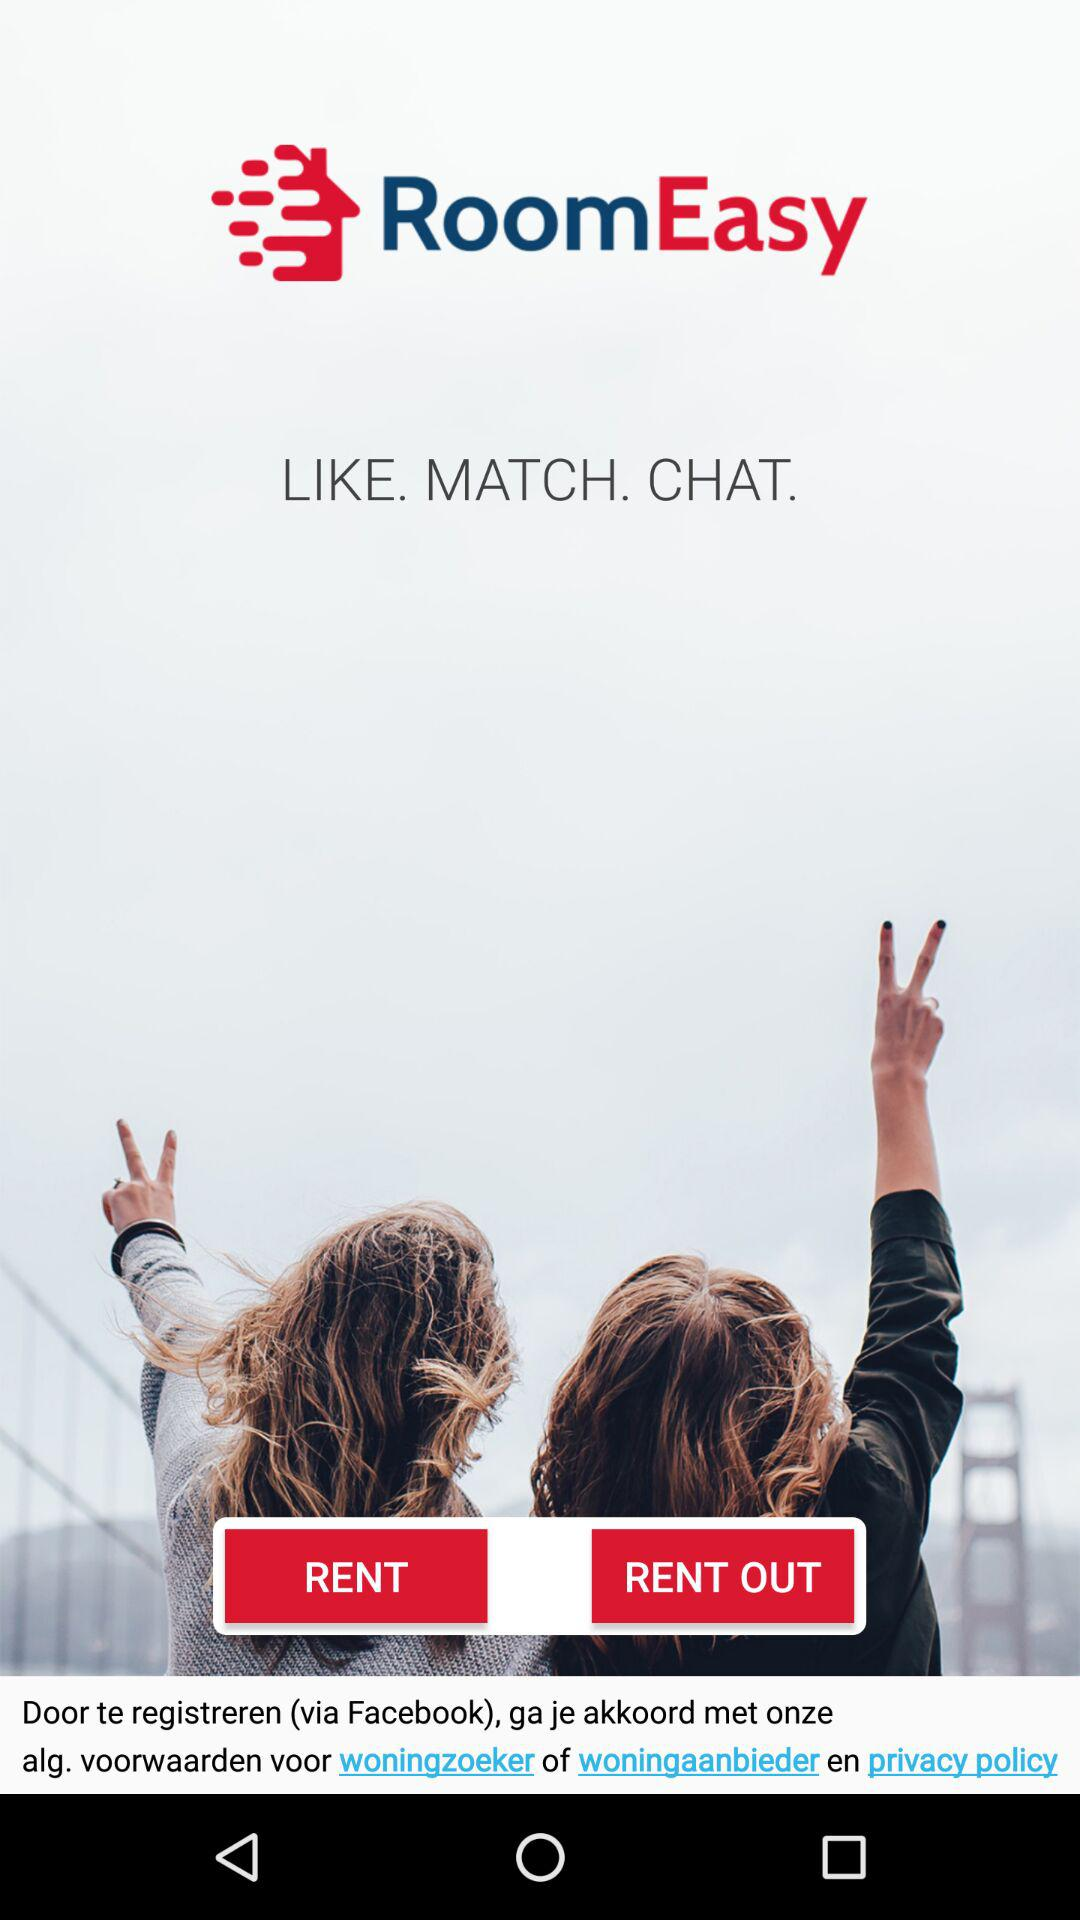What is the name of the application? The name of the application is "RoomEasy". 